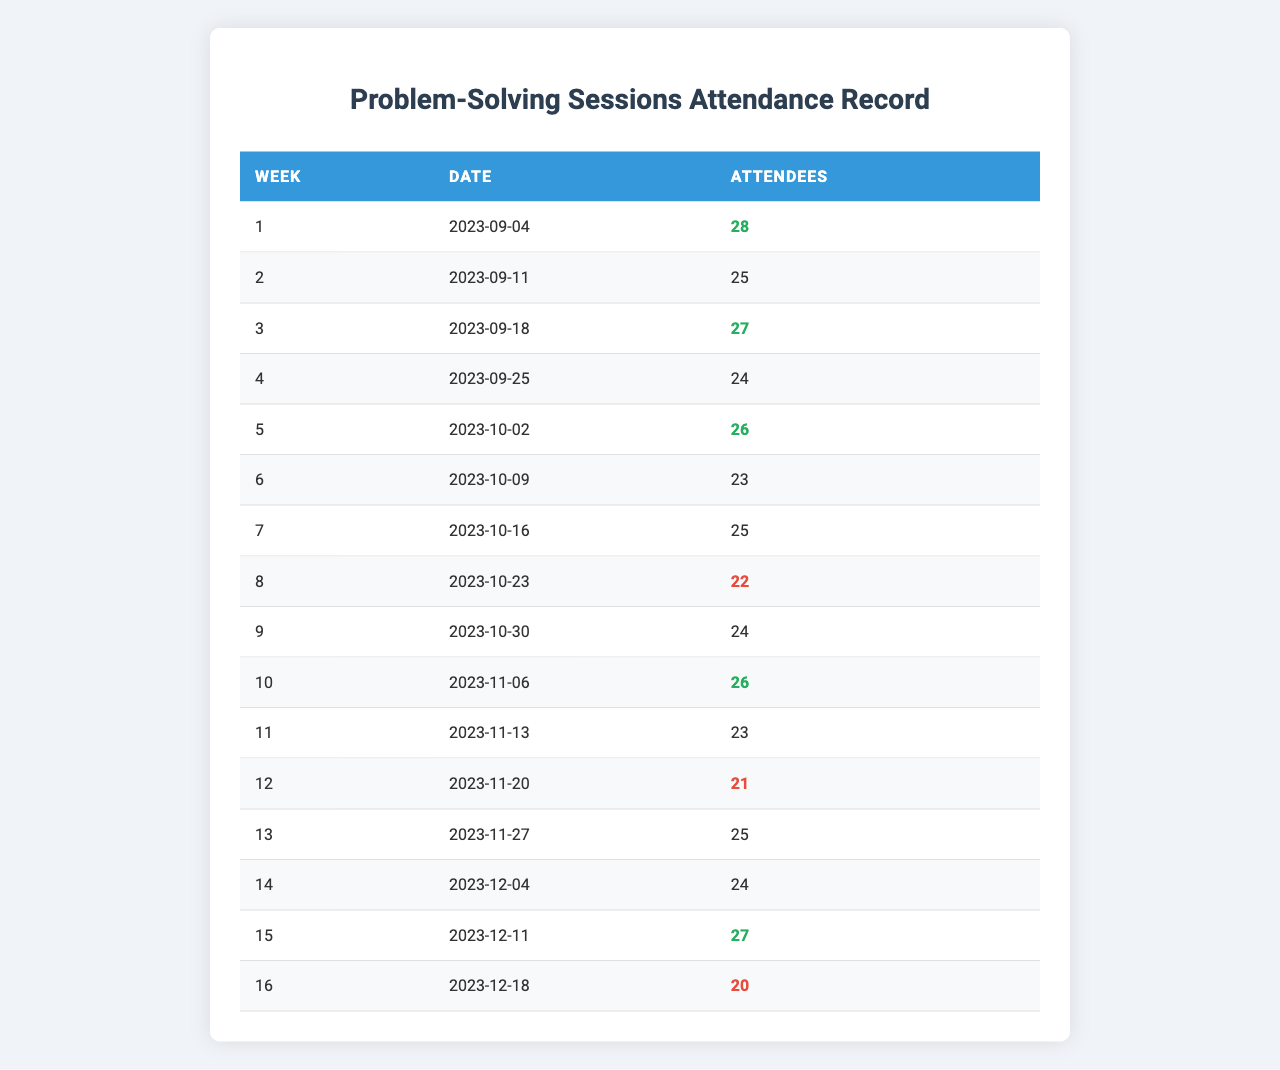What is the attendance for week 3? Referring to the table, the number of attendees for week 3 is directly listed as 27.
Answer: 27 What was the date of the session in week 5? The table states that the date for week 5 is 2023-10-02.
Answer: 2023-10-02 Is the attendance for week 12 higher than 22? By checking the table, week 12 has an attendance of 21, which is lower than 22.
Answer: No What is the average attendance over all sessions? To find the average, first sum the attendees: 28 + 25 + 27 + 24 + 26 + 23 + 25 + 22 + 24 + 26 + 23 + 21 + 25 + 24 + 27 + 20 = 377. There are 16 weeks, so the average is 377 / 16 = 23.5625, which rounds to 23.6.
Answer: 23.6 Which week had the lowest attendance? Review the table for the lowest attendee count; week 16 has the lowest at 20 attendees.
Answer: Week 16 How many attendees were present in total for weeks 1 to 4? Adding the attendees for those weeks: 28 (week 1) + 25 (week 2) + 27 (week 3) + 24 (week 4) = 104.
Answer: 104 Does any week have exactly 22 attendees? By checking the data in the table, only week 8 has 22 attendees.
Answer: Yes How many weeks had attendance of 26 or higher? Checking the table, the weeks with 26 or higher are weeks 1, 3, 5, 10, 13, and 15, which totals to 6 weeks.
Answer: 6 What was the difference in attendance between the first and last session? The first session had 28 attendees and the last had 20, so the difference is 28 - 20 = 8.
Answer: 8 Which weeks had attendance lower than the average? The average calculated is 23.6, so the weeks with fewer attendees are weeks 6 (23), 8 (22), 11 (23), 12 (21), and 16 (20). That's a total of 5 weeks.
Answer: 5 